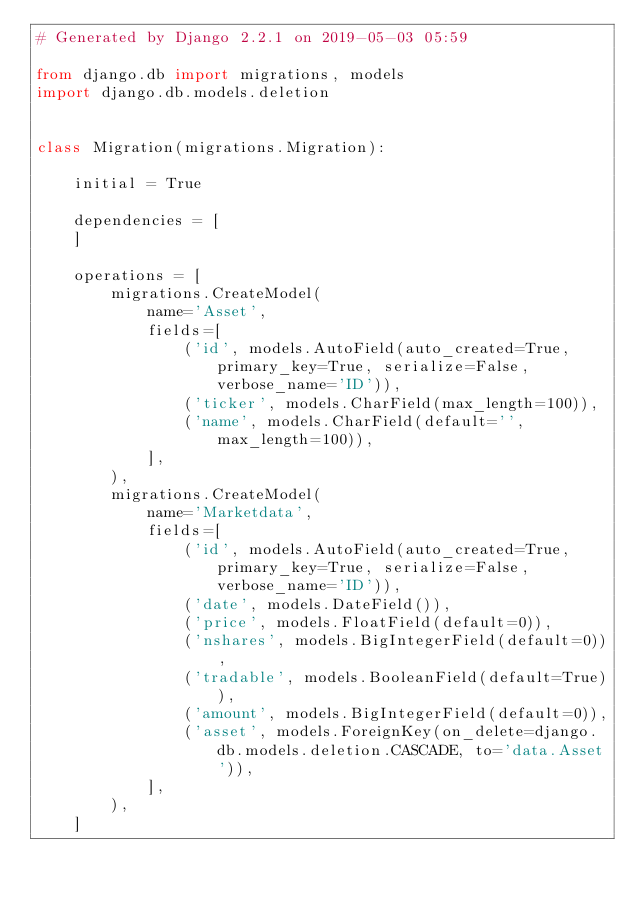<code> <loc_0><loc_0><loc_500><loc_500><_Python_># Generated by Django 2.2.1 on 2019-05-03 05:59

from django.db import migrations, models
import django.db.models.deletion


class Migration(migrations.Migration):

    initial = True

    dependencies = [
    ]

    operations = [
        migrations.CreateModel(
            name='Asset',
            fields=[
                ('id', models.AutoField(auto_created=True, primary_key=True, serialize=False, verbose_name='ID')),
                ('ticker', models.CharField(max_length=100)),
                ('name', models.CharField(default='', max_length=100)),
            ],
        ),
        migrations.CreateModel(
            name='Marketdata',
            fields=[
                ('id', models.AutoField(auto_created=True, primary_key=True, serialize=False, verbose_name='ID')),
                ('date', models.DateField()),
                ('price', models.FloatField(default=0)),
                ('nshares', models.BigIntegerField(default=0)),
                ('tradable', models.BooleanField(default=True)),
                ('amount', models.BigIntegerField(default=0)),
                ('asset', models.ForeignKey(on_delete=django.db.models.deletion.CASCADE, to='data.Asset')),
            ],
        ),
    ]
</code> 